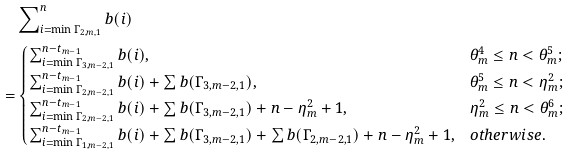Convert formula to latex. <formula><loc_0><loc_0><loc_500><loc_500>& \sum \nolimits _ { i = \min \Gamma _ { 2 , m , 1 } } ^ { n } b ( i ) \\ = & \begin{cases} \sum _ { i = \min \Gamma _ { 3 , m - 2 , 1 } } ^ { n - t _ { m - 1 } } b ( i ) , & \theta _ { m } ^ { 4 } \leq n < \theta _ { m } ^ { 5 } ; \\ \sum _ { i = \min \Gamma _ { 2 , m - 2 , 1 } } ^ { n - t _ { m - 1 } } b ( i ) + \sum b ( \Gamma _ { 3 , m - 2 , 1 } ) , & \theta _ { m } ^ { 5 } \leq n < \eta _ { m } ^ { 2 } ; \\ \sum _ { i = \min \Gamma _ { 2 , m - 2 , 1 } } ^ { n - t _ { m - 1 } } b ( i ) + \sum b ( \Gamma _ { 3 , m - 2 , 1 } ) + n - \eta _ { m } ^ { 2 } + 1 , & \eta _ { m } ^ { 2 } \leq n < \theta _ { m } ^ { 6 } ; \\ \sum _ { i = \min \Gamma _ { 1 , m - 2 , 1 } } ^ { n - t _ { m - 1 } } b ( i ) + \sum b ( \Gamma _ { 3 , m - 2 , 1 } ) + \sum b ( \Gamma _ { 2 , m - 2 , 1 } ) + n - \eta _ { m } ^ { 2 } + 1 , & o t h e r w i s e . \end{cases}</formula> 